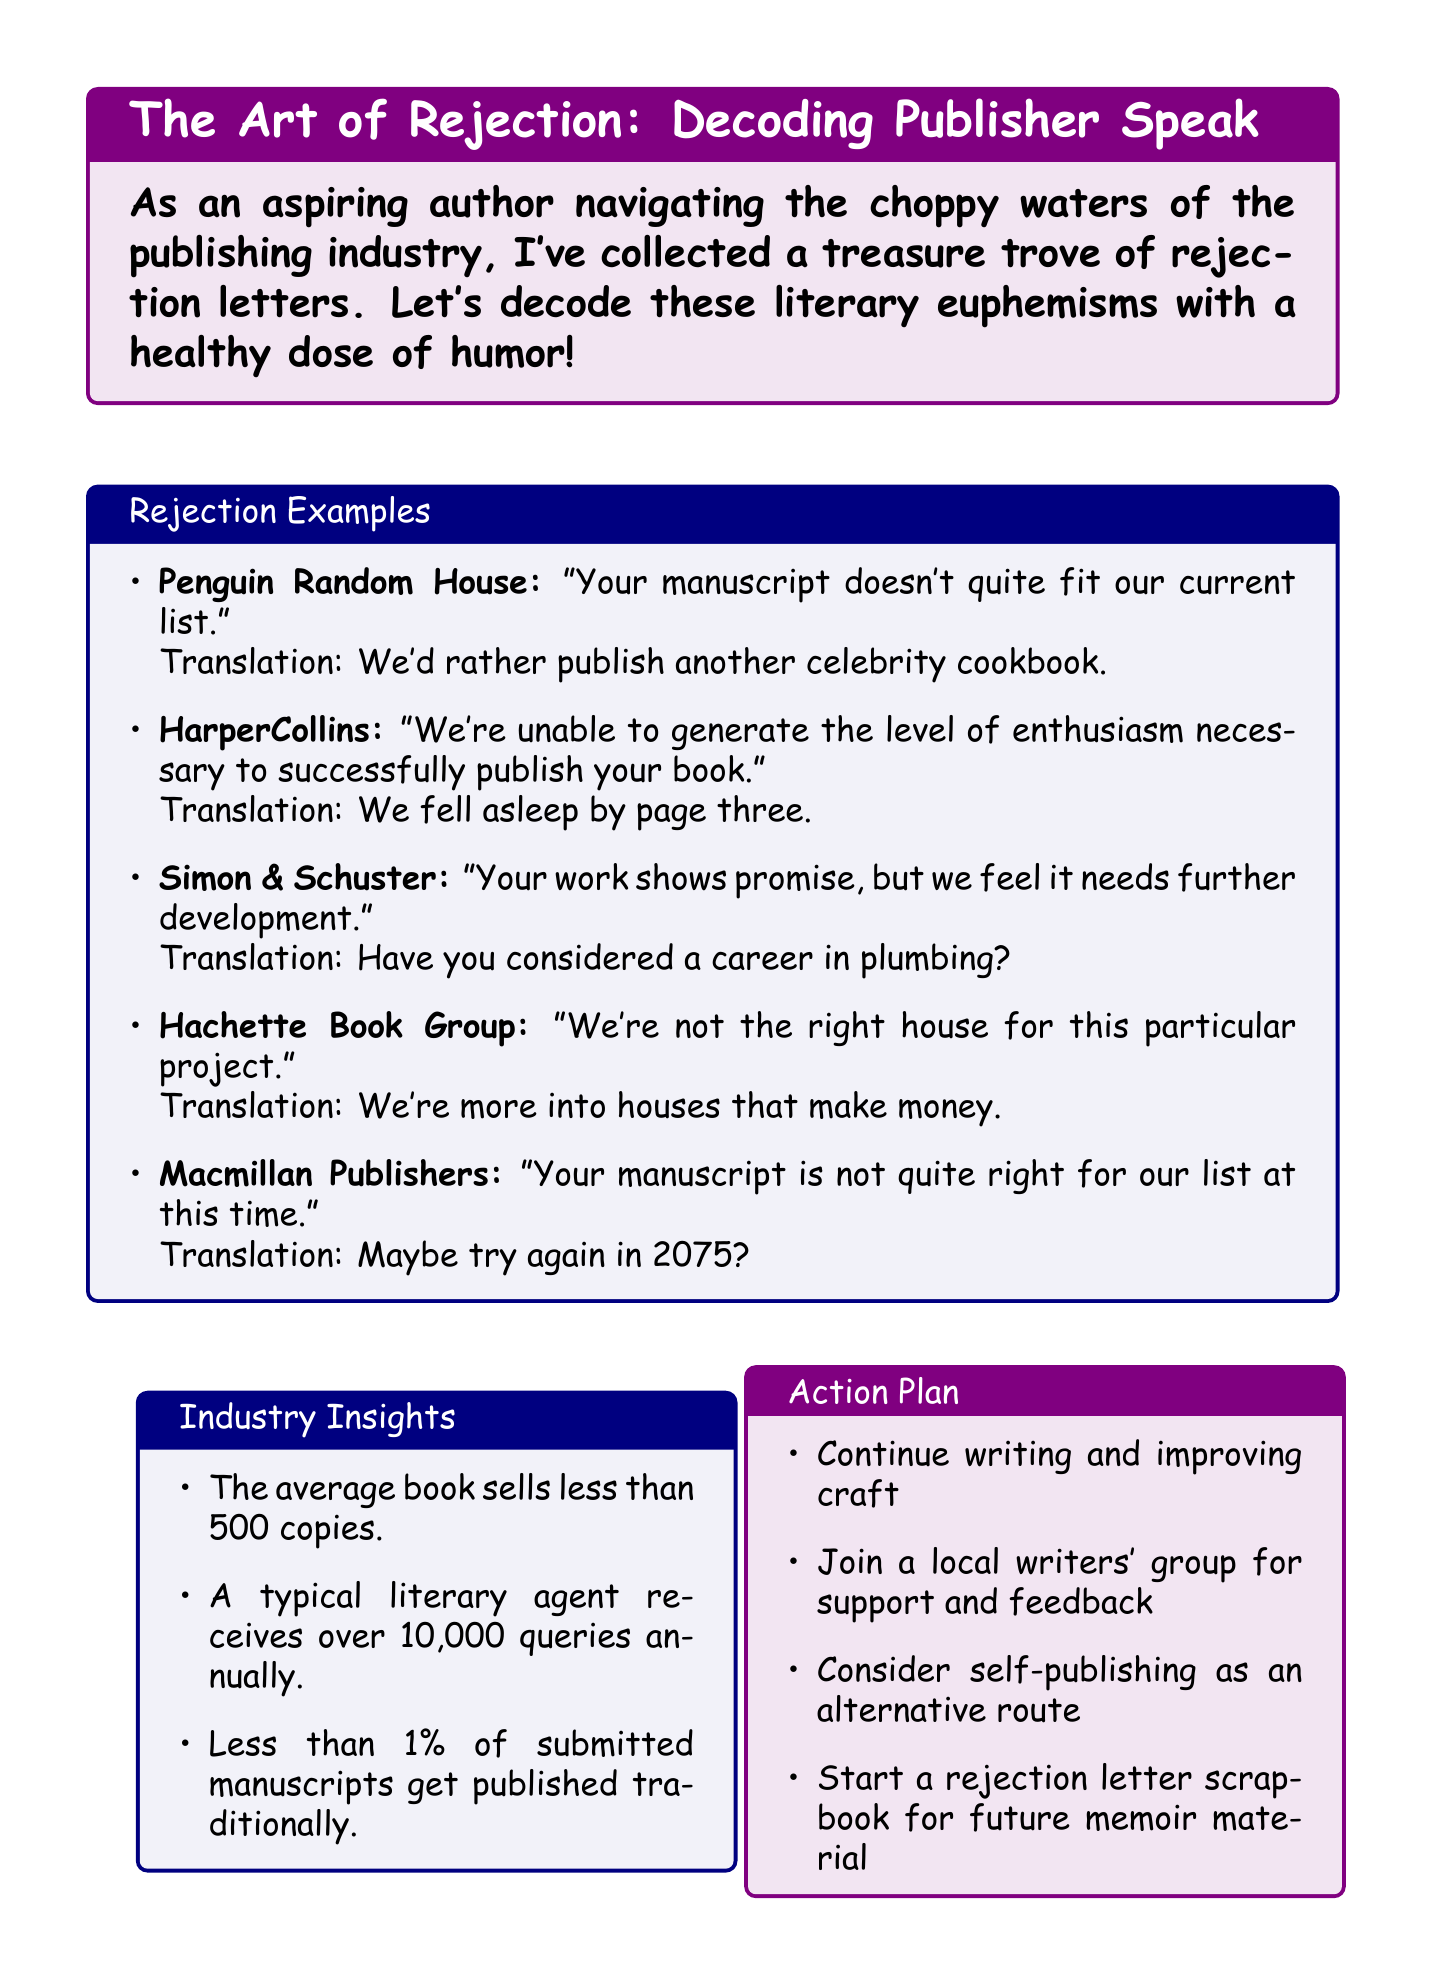What is the title of the memo? The title of the memo is located at the beginning of the document in a prominent box.
Answer: The Art of Rejection: Decoding Publisher Speak Who published the humorous rejection examples? The humorous rejection examples come from various publishers mentioned in the document.
Answer: Various publishers What is the translation of the rejection from Penguin Random House? The translation of each euphemism can be found directly following the publisher's statement in the rejection examples section.
Answer: We'd rather publish another celebrity cookbook What percentage of submitted manuscripts get published traditionally? This percentage is provided in the industry insights section of the document.
Answer: Less than 1% What is one item included in the action plan? The action plan contains various goals listed in a box, from which specific items can be retrieved.
Answer: Continue writing and improving craft How many rejections did Stephen King's 'Carrie' receive before publication? The personal reflection portion of the memoir mentions this specific number of rejections.
Answer: 30 What is the color scheme used in the memo? The document features distinct color-coded sections with specific colors for boxes and text; these are described in the formatting.
Answer: Purple and blue What should aspiring authors do according to the conclusion? The conclusion encourages further actions and attitudes for aspiring authors, stated at the end of the document.
Answer: Keep writing, keep submitting, and keep laughing 